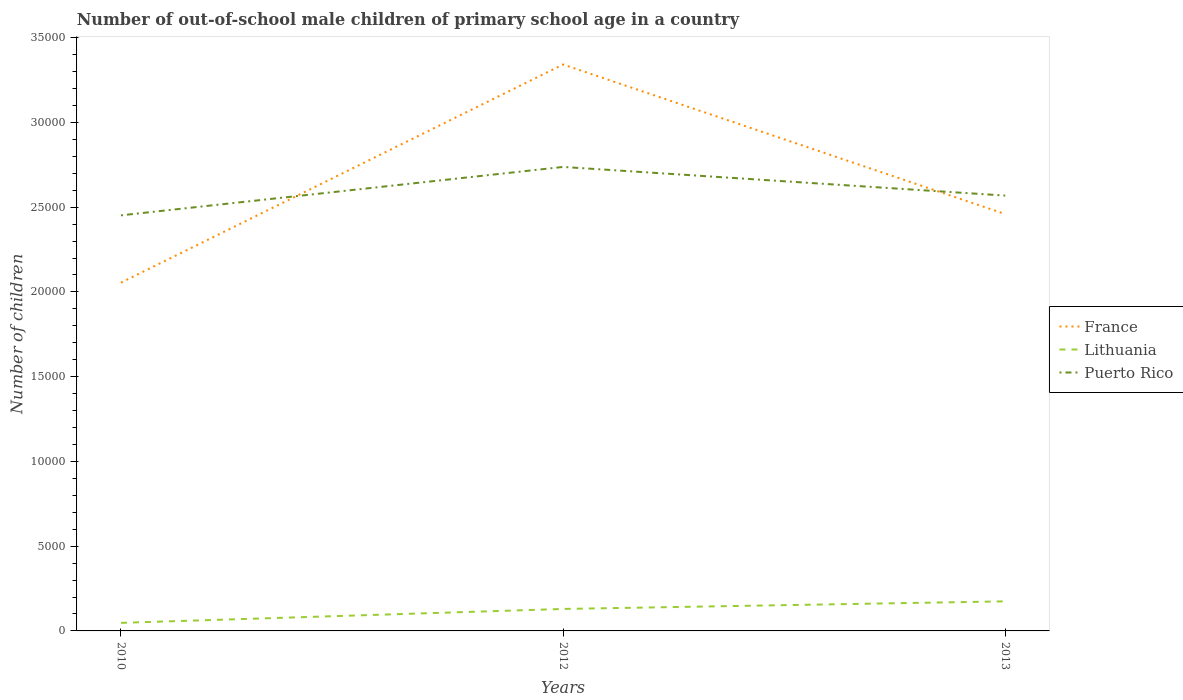Is the number of lines equal to the number of legend labels?
Make the answer very short. Yes. Across all years, what is the maximum number of out-of-school male children in France?
Your response must be concise. 2.06e+04. In which year was the number of out-of-school male children in Puerto Rico maximum?
Your answer should be compact. 2010. What is the total number of out-of-school male children in France in the graph?
Keep it short and to the point. 8826. What is the difference between the highest and the second highest number of out-of-school male children in Puerto Rico?
Ensure brevity in your answer.  2856. How many years are there in the graph?
Your response must be concise. 3. What is the difference between two consecutive major ticks on the Y-axis?
Make the answer very short. 5000. How are the legend labels stacked?
Your answer should be very brief. Vertical. What is the title of the graph?
Your answer should be very brief. Number of out-of-school male children of primary school age in a country. What is the label or title of the X-axis?
Give a very brief answer. Years. What is the label or title of the Y-axis?
Your response must be concise. Number of children. What is the Number of children in France in 2010?
Provide a short and direct response. 2.06e+04. What is the Number of children in Lithuania in 2010?
Your response must be concise. 476. What is the Number of children of Puerto Rico in 2010?
Your answer should be very brief. 2.45e+04. What is the Number of children in France in 2012?
Your answer should be very brief. 3.34e+04. What is the Number of children of Lithuania in 2012?
Ensure brevity in your answer.  1296. What is the Number of children of Puerto Rico in 2012?
Offer a very short reply. 2.74e+04. What is the Number of children in France in 2013?
Offer a terse response. 2.46e+04. What is the Number of children in Lithuania in 2013?
Ensure brevity in your answer.  1745. What is the Number of children in Puerto Rico in 2013?
Give a very brief answer. 2.57e+04. Across all years, what is the maximum Number of children of France?
Make the answer very short. 3.34e+04. Across all years, what is the maximum Number of children of Lithuania?
Keep it short and to the point. 1745. Across all years, what is the maximum Number of children in Puerto Rico?
Make the answer very short. 2.74e+04. Across all years, what is the minimum Number of children of France?
Your answer should be very brief. 2.06e+04. Across all years, what is the minimum Number of children in Lithuania?
Offer a very short reply. 476. Across all years, what is the minimum Number of children of Puerto Rico?
Your response must be concise. 2.45e+04. What is the total Number of children in France in the graph?
Offer a terse response. 7.86e+04. What is the total Number of children of Lithuania in the graph?
Your response must be concise. 3517. What is the total Number of children in Puerto Rico in the graph?
Your answer should be compact. 7.76e+04. What is the difference between the Number of children in France in 2010 and that in 2012?
Make the answer very short. -1.29e+04. What is the difference between the Number of children in Lithuania in 2010 and that in 2012?
Provide a short and direct response. -820. What is the difference between the Number of children in Puerto Rico in 2010 and that in 2012?
Your answer should be compact. -2856. What is the difference between the Number of children of France in 2010 and that in 2013?
Offer a terse response. -4044. What is the difference between the Number of children in Lithuania in 2010 and that in 2013?
Ensure brevity in your answer.  -1269. What is the difference between the Number of children in Puerto Rico in 2010 and that in 2013?
Give a very brief answer. -1165. What is the difference between the Number of children of France in 2012 and that in 2013?
Your answer should be compact. 8826. What is the difference between the Number of children in Lithuania in 2012 and that in 2013?
Ensure brevity in your answer.  -449. What is the difference between the Number of children in Puerto Rico in 2012 and that in 2013?
Your answer should be compact. 1691. What is the difference between the Number of children of France in 2010 and the Number of children of Lithuania in 2012?
Make the answer very short. 1.93e+04. What is the difference between the Number of children in France in 2010 and the Number of children in Puerto Rico in 2012?
Offer a terse response. -6826. What is the difference between the Number of children in Lithuania in 2010 and the Number of children in Puerto Rico in 2012?
Your response must be concise. -2.69e+04. What is the difference between the Number of children in France in 2010 and the Number of children in Lithuania in 2013?
Offer a very short reply. 1.88e+04. What is the difference between the Number of children in France in 2010 and the Number of children in Puerto Rico in 2013?
Provide a succinct answer. -5135. What is the difference between the Number of children of Lithuania in 2010 and the Number of children of Puerto Rico in 2013?
Provide a short and direct response. -2.52e+04. What is the difference between the Number of children in France in 2012 and the Number of children in Lithuania in 2013?
Keep it short and to the point. 3.17e+04. What is the difference between the Number of children of France in 2012 and the Number of children of Puerto Rico in 2013?
Make the answer very short. 7735. What is the difference between the Number of children of Lithuania in 2012 and the Number of children of Puerto Rico in 2013?
Provide a succinct answer. -2.44e+04. What is the average Number of children of France per year?
Make the answer very short. 2.62e+04. What is the average Number of children in Lithuania per year?
Offer a terse response. 1172.33. What is the average Number of children of Puerto Rico per year?
Offer a very short reply. 2.59e+04. In the year 2010, what is the difference between the Number of children in France and Number of children in Lithuania?
Your answer should be very brief. 2.01e+04. In the year 2010, what is the difference between the Number of children of France and Number of children of Puerto Rico?
Ensure brevity in your answer.  -3970. In the year 2010, what is the difference between the Number of children in Lithuania and Number of children in Puerto Rico?
Give a very brief answer. -2.40e+04. In the year 2012, what is the difference between the Number of children in France and Number of children in Lithuania?
Offer a terse response. 3.21e+04. In the year 2012, what is the difference between the Number of children in France and Number of children in Puerto Rico?
Your answer should be very brief. 6044. In the year 2012, what is the difference between the Number of children of Lithuania and Number of children of Puerto Rico?
Offer a terse response. -2.61e+04. In the year 2013, what is the difference between the Number of children of France and Number of children of Lithuania?
Your answer should be very brief. 2.28e+04. In the year 2013, what is the difference between the Number of children of France and Number of children of Puerto Rico?
Your answer should be compact. -1091. In the year 2013, what is the difference between the Number of children of Lithuania and Number of children of Puerto Rico?
Offer a terse response. -2.39e+04. What is the ratio of the Number of children in France in 2010 to that in 2012?
Your answer should be compact. 0.61. What is the ratio of the Number of children of Lithuania in 2010 to that in 2012?
Your answer should be very brief. 0.37. What is the ratio of the Number of children in Puerto Rico in 2010 to that in 2012?
Provide a succinct answer. 0.9. What is the ratio of the Number of children of France in 2010 to that in 2013?
Offer a very short reply. 0.84. What is the ratio of the Number of children in Lithuania in 2010 to that in 2013?
Provide a short and direct response. 0.27. What is the ratio of the Number of children of Puerto Rico in 2010 to that in 2013?
Keep it short and to the point. 0.95. What is the ratio of the Number of children in France in 2012 to that in 2013?
Provide a succinct answer. 1.36. What is the ratio of the Number of children in Lithuania in 2012 to that in 2013?
Make the answer very short. 0.74. What is the ratio of the Number of children of Puerto Rico in 2012 to that in 2013?
Keep it short and to the point. 1.07. What is the difference between the highest and the second highest Number of children in France?
Offer a terse response. 8826. What is the difference between the highest and the second highest Number of children in Lithuania?
Provide a short and direct response. 449. What is the difference between the highest and the second highest Number of children of Puerto Rico?
Your answer should be compact. 1691. What is the difference between the highest and the lowest Number of children of France?
Make the answer very short. 1.29e+04. What is the difference between the highest and the lowest Number of children of Lithuania?
Provide a short and direct response. 1269. What is the difference between the highest and the lowest Number of children in Puerto Rico?
Make the answer very short. 2856. 